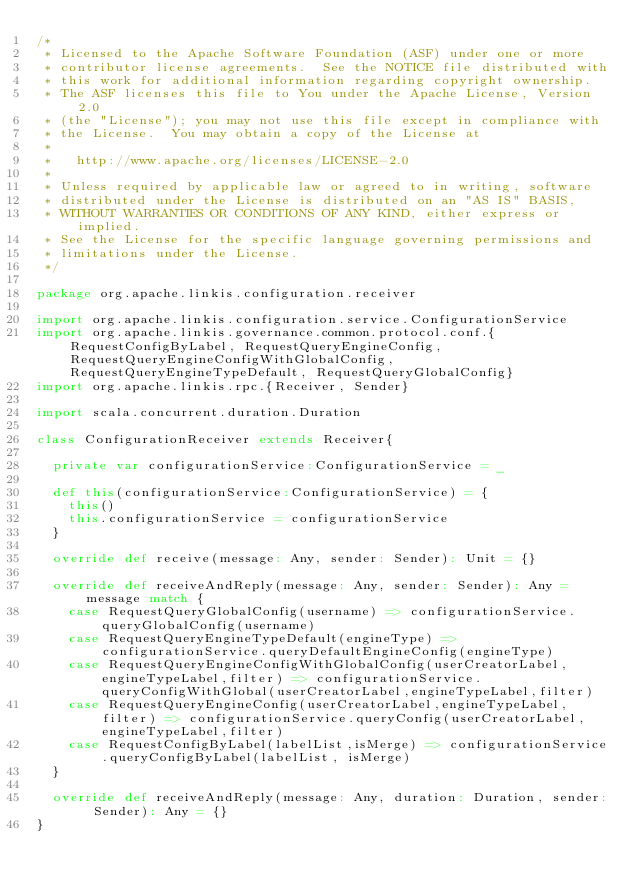<code> <loc_0><loc_0><loc_500><loc_500><_Scala_>/*
 * Licensed to the Apache Software Foundation (ASF) under one or more
 * contributor license agreements.  See the NOTICE file distributed with
 * this work for additional information regarding copyright ownership.
 * The ASF licenses this file to You under the Apache License, Version 2.0
 * (the "License"); you may not use this file except in compliance with
 * the License.  You may obtain a copy of the License at
 * 
 *   http://www.apache.org/licenses/LICENSE-2.0
 * 
 * Unless required by applicable law or agreed to in writing, software
 * distributed under the License is distributed on an "AS IS" BASIS,
 * WITHOUT WARRANTIES OR CONDITIONS OF ANY KIND, either express or implied.
 * See the License for the specific language governing permissions and
 * limitations under the License.
 */
 
package org.apache.linkis.configuration.receiver

import org.apache.linkis.configuration.service.ConfigurationService
import org.apache.linkis.governance.common.protocol.conf.{RequestConfigByLabel, RequestQueryEngineConfig, RequestQueryEngineConfigWithGlobalConfig, RequestQueryEngineTypeDefault, RequestQueryGlobalConfig}
import org.apache.linkis.rpc.{Receiver, Sender}

import scala.concurrent.duration.Duration

class ConfigurationReceiver extends Receiver{

  private var configurationService:ConfigurationService = _

  def this(configurationService:ConfigurationService) = {
    this()
    this.configurationService = configurationService
  }

  override def receive(message: Any, sender: Sender): Unit = {}

  override def receiveAndReply(message: Any, sender: Sender): Any = message match {
    case RequestQueryGlobalConfig(username) => configurationService.queryGlobalConfig(username)
    case RequestQueryEngineTypeDefault(engineType) => configurationService.queryDefaultEngineConfig(engineType)
    case RequestQueryEngineConfigWithGlobalConfig(userCreatorLabel,engineTypeLabel,filter) => configurationService.queryConfigWithGlobal(userCreatorLabel,engineTypeLabel,filter)
    case RequestQueryEngineConfig(userCreatorLabel,engineTypeLabel,filter) => configurationService.queryConfig(userCreatorLabel,engineTypeLabel,filter)
    case RequestConfigByLabel(labelList,isMerge) => configurationService.queryConfigByLabel(labelList, isMerge)
  }

  override def receiveAndReply(message: Any, duration: Duration, sender: Sender): Any = {}
}
</code> 